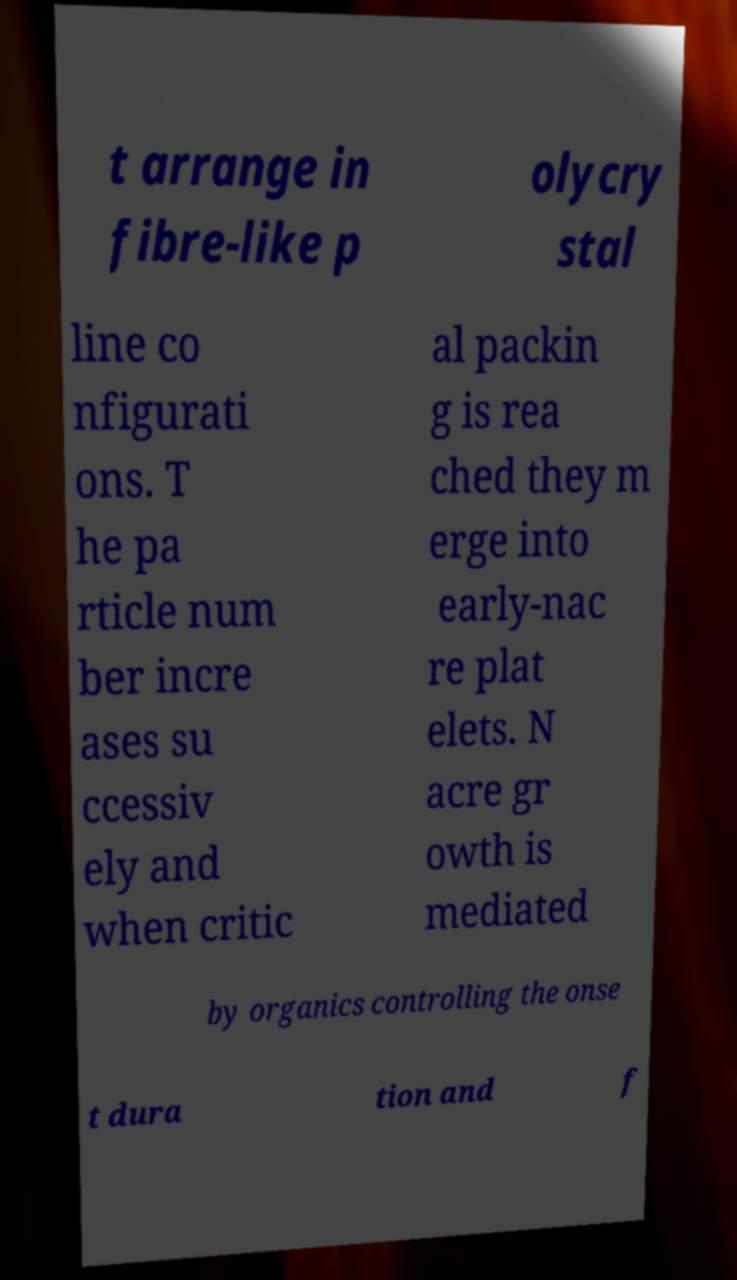I need the written content from this picture converted into text. Can you do that? t arrange in fibre-like p olycry stal line co nfigurati ons. T he pa rticle num ber incre ases su ccessiv ely and when critic al packin g is rea ched they m erge into early-nac re plat elets. N acre gr owth is mediated by organics controlling the onse t dura tion and f 